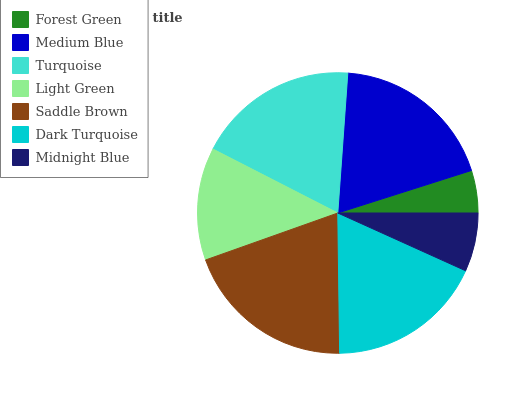Is Forest Green the minimum?
Answer yes or no. Yes. Is Saddle Brown the maximum?
Answer yes or no. Yes. Is Medium Blue the minimum?
Answer yes or no. No. Is Medium Blue the maximum?
Answer yes or no. No. Is Medium Blue greater than Forest Green?
Answer yes or no. Yes. Is Forest Green less than Medium Blue?
Answer yes or no. Yes. Is Forest Green greater than Medium Blue?
Answer yes or no. No. Is Medium Blue less than Forest Green?
Answer yes or no. No. Is Dark Turquoise the high median?
Answer yes or no. Yes. Is Dark Turquoise the low median?
Answer yes or no. Yes. Is Light Green the high median?
Answer yes or no. No. Is Medium Blue the low median?
Answer yes or no. No. 